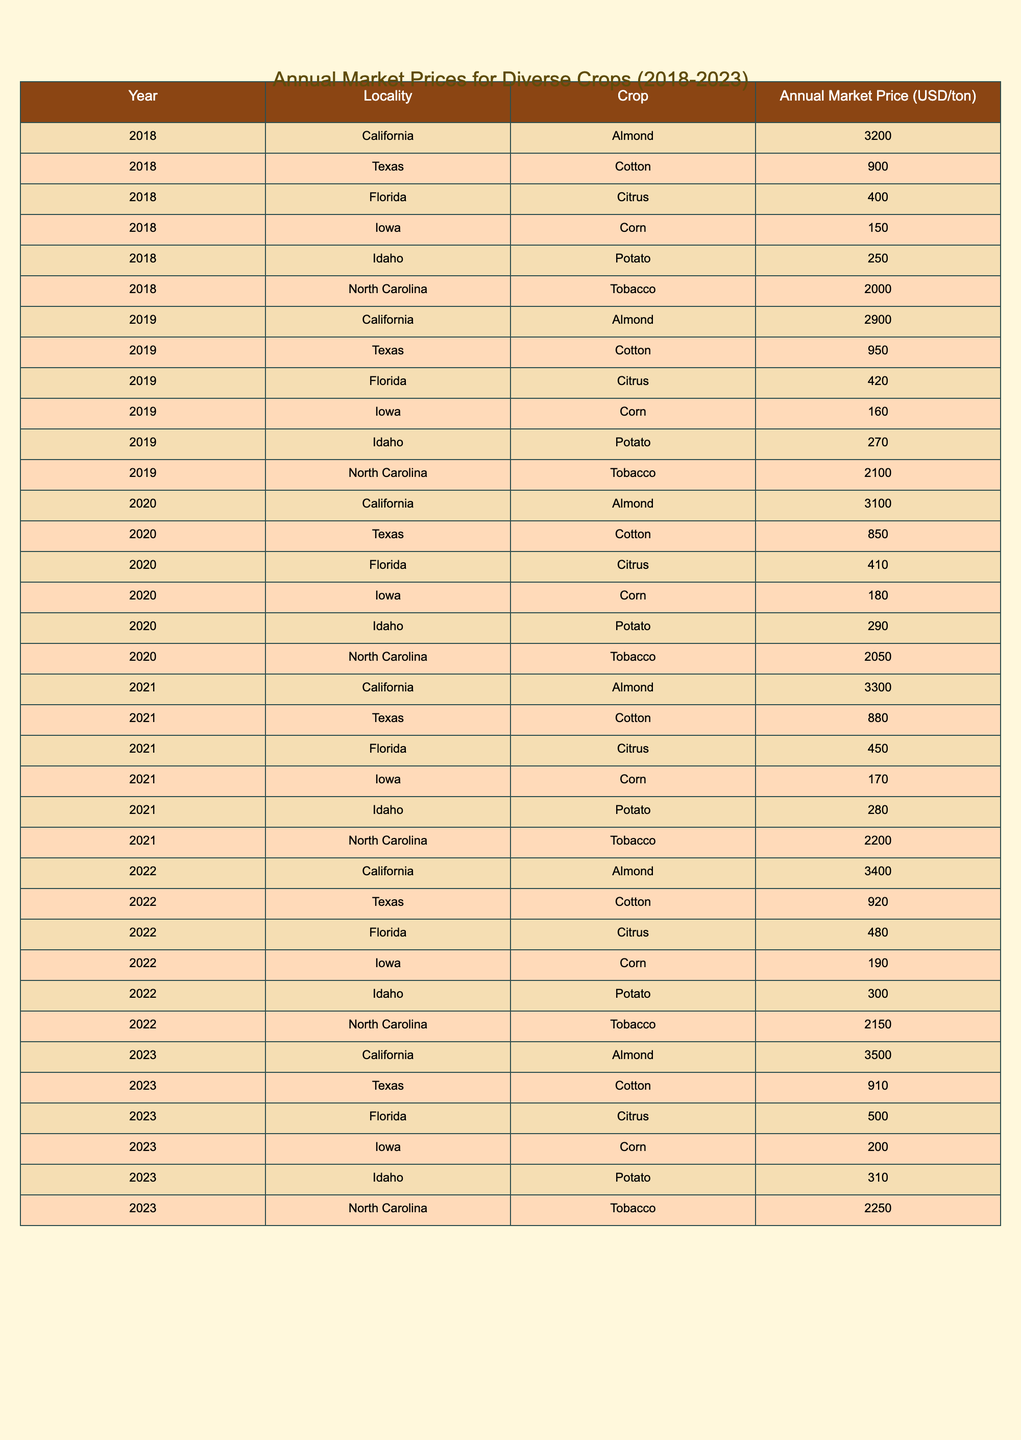What was the market price for Almonds in California in 2023? In the table, I check the row corresponding to California for the year 2023, which indicates the market price for Almonds is 3500 USD per ton.
Answer: 3500 What was the highest annual market price for Corn during the years 2018 to 2023? I look through the rows for Corn from 2018 to 2023. The highest price appears in 2023 at 200 USD per ton.
Answer: 200 Did the market price for Citrus in Florida increase from 2022 to 2023? I compare the prices listed for Citrus in Florida for both years: in 2022 it was 480 USD, and in 2023 it increased to 500 USD. Hence, it did increase.
Answer: Yes What was the average annual market price for Tobacco from 2018 to 2023? I sum the market prices for Tobacco across the years: (2000 + 2100 + 2050 + 2200 + 2150 + 2250) = 12950. Then, I divide by the number of years (6), which gives 12950 / 6 = 2158.33, rounding to 2158.
Answer: 2158 Which crop had the lowest market price in Texas in 2020? I check the row for Texas in 2020. The options are Cotton at 850 USD, and no other crops are listed for Texas in that year, making Cotton the lowest.
Answer: Cotton What was the percentage increase in the market price of Potatoes in Idaho from 2018 to 2023? I find the price for Idaho Potatoes in 2018 (250 USD) and in 2023 (310 USD). The increase is 310 - 250 = 60 USD. The percentage increase is (60 / 250) * 100 = 24%.
Answer: 24% Was the market price for Almonds in California higher than that of Corn in Iowa in 2021? I locate the price of Almonds in California for 2021 (3300 USD) and Corn in Iowa for the same year (170 USD). Since 3300 is greater than 170, Almonds were indeed higher.
Answer: Yes What trend can be observed in the annual market price of Cotton in Texas from 2018 to 2023? I examine the prices for Cotton in Texas over the years: 900, 950, 850, 880, 920, and 910. The prices fluctuate but generally show a slight upward trend from 2019 to 2022, then a slight decrease in 2020 followed by a small recovery in 2023.
Answer: Fluctuating with a slight upward trend Which crop had the smallest market price increase from 2022 to 2023 in Florida? I check the prices for Citrus in Florida: 480 USD in 2022 and 500 USD in 2023, which is an increase of 20 USD, the only crop listed for Florida in this period is Citrus. Therefore, it is the answer.
Answer: Citrus What is the total market price of Almonds sold in California from 2018 to 2023? I sum the prices listed for Almonds in California for each year: 3200 + 2900 + 3100 + 3300 + 3400 + 3500 = 19400 USD.
Answer: 19400 